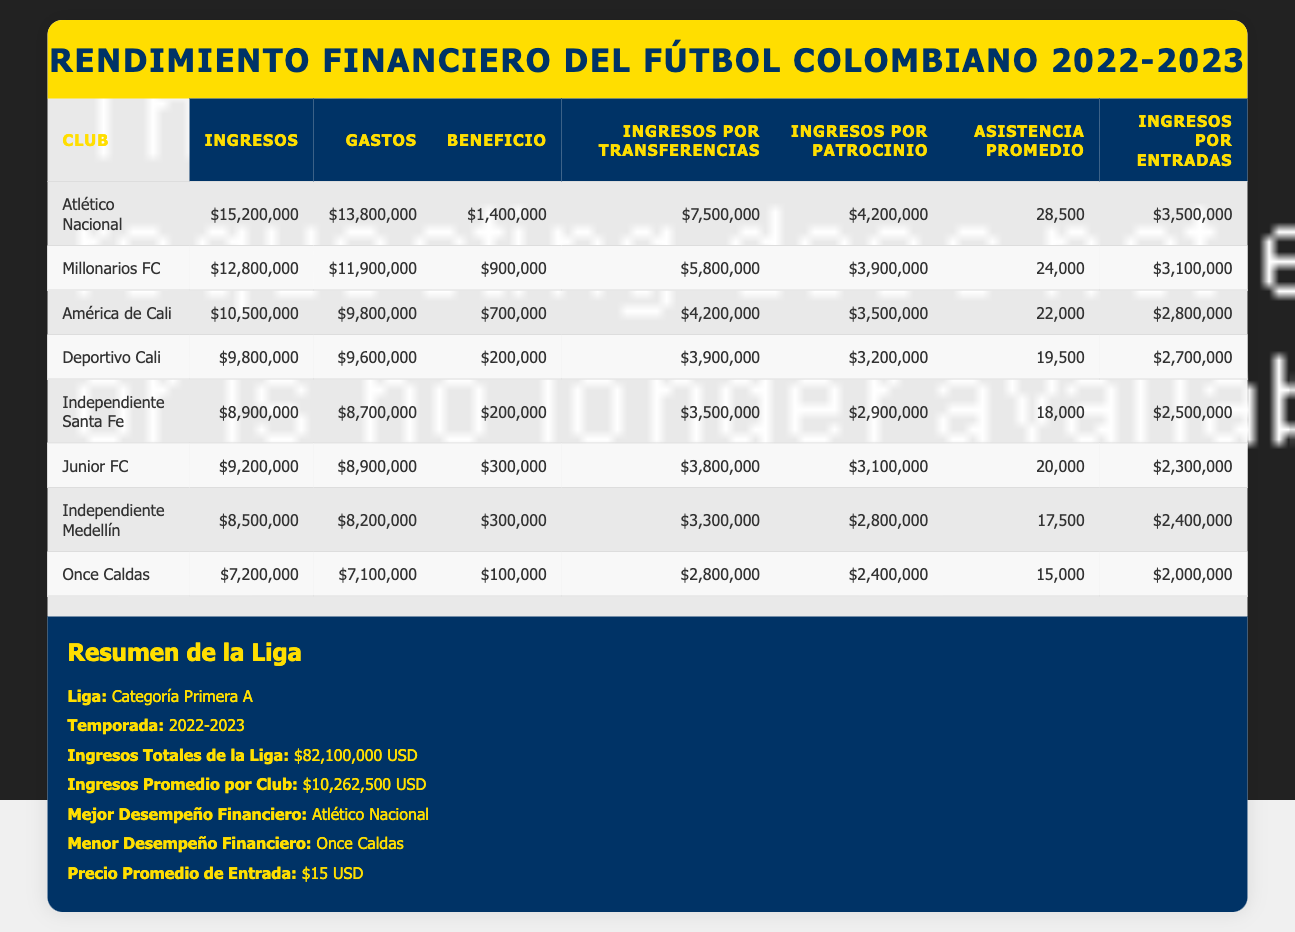What was the profit of Atlético Nacional? From the table, we can see that Atlético Nacional has a profit of $1,400,000 listed in the Profit column.
Answer: $1,400,000 Which club had the highest revenue? The highest revenue is found in the Revenue column, where Atlético Nacional is listed with $15,200,000 as its revenue.
Answer: Atlético Nacional What is the average attendance of Independiente Santa Fe? The average attendance for Independiente Santa Fe is listed in the Average Attendance column as 18,000.
Answer: 18,000 How much did Once Caldas earn from transfer income? In the Transfer Income column for Once Caldas, the amount is shown as $2,800,000.
Answer: $2,800,000 Did Atlético Nacional have higher expenses than Millonarios FC? We can find that Atlético Nacional's expenses are $13,800,000 and Millonarios FC's expenses are $11,900,000. Since $13,800,000 is greater than $11,900,000, the answer is yes.
Answer: Yes What is the total revenue of the top three clubs? The top three clubs based on revenue are Atlético Nacional ($15,200,000), Millonarios FC ($12,800,000), and América de Cali ($10,500,000). Adding these amounts gives us $15,200,000 + $12,800,000 + $10,500,000 = $38,500,000.
Answer: $38,500,000 Is Independiente Medellín's profit higher than Junior FC's profit? Independiente Medellín has a profit of $300,000, while Junior FC also has a profit of $300,000. Since both are equal, the answer is no.
Answer: No What is the average profit of all clubs in the table? To find the average profit, we sum the profits of all clubs: $1,400,000 (Atlético Nacional) + $900,000 (Millonarios FC) + $700,000 (América de Cali) + $200,000 (Deportivo Cali) + $200,000 (Independiente Santa Fe) + $300,000 (Junior FC) + $300,000 (Independiente Medellín) + $100,000 (Once Caldas) = $3,100,000. There are 8 clubs, so the average profit is $3,100,000 / 8 = $387,500.
Answer: $387,500 Which club earned the most from sponsorship income? Looking at the Sponsorship Income column, Atlético Nacional earned $4,200,000, which is the highest among all clubs listed.
Answer: Atlético Nacional Was the total revenue of the league greater than $80 million? The total league revenue is reported as $82,100,000, which is indeed greater than $80 million.
Answer: Yes 